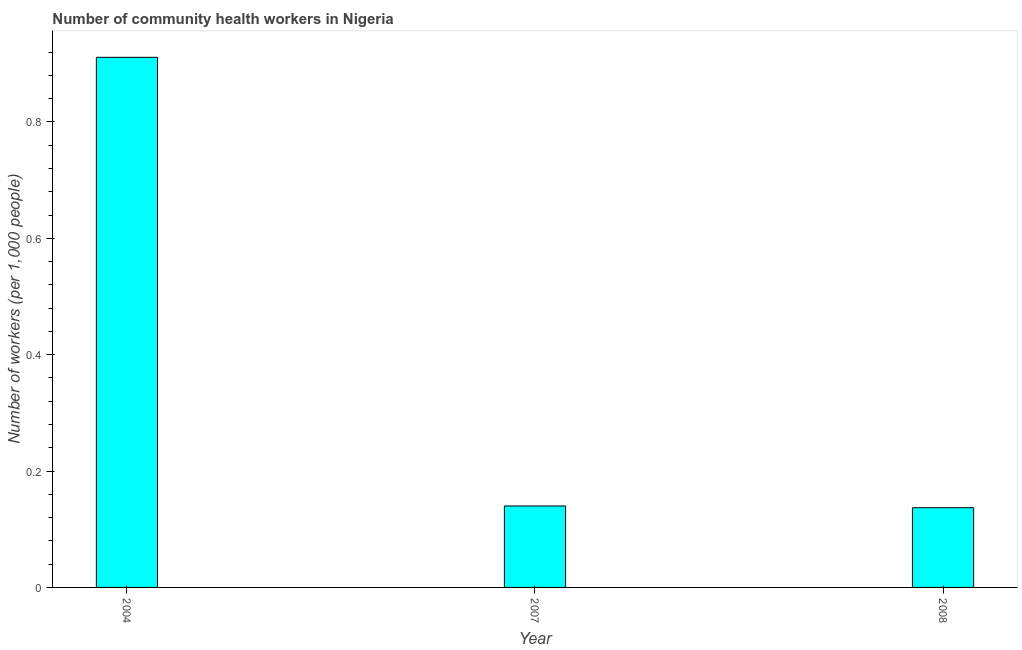Does the graph contain any zero values?
Make the answer very short. No. What is the title of the graph?
Keep it short and to the point. Number of community health workers in Nigeria. What is the label or title of the Y-axis?
Provide a succinct answer. Number of workers (per 1,0 people). What is the number of community health workers in 2008?
Your answer should be very brief. 0.14. Across all years, what is the maximum number of community health workers?
Your response must be concise. 0.91. Across all years, what is the minimum number of community health workers?
Keep it short and to the point. 0.14. What is the sum of the number of community health workers?
Keep it short and to the point. 1.19. What is the difference between the number of community health workers in 2004 and 2007?
Keep it short and to the point. 0.77. What is the average number of community health workers per year?
Give a very brief answer. 0.4. What is the median number of community health workers?
Offer a terse response. 0.14. In how many years, is the number of community health workers greater than 0.48 ?
Your response must be concise. 1. What is the ratio of the number of community health workers in 2004 to that in 2008?
Give a very brief answer. 6.65. Is the difference between the number of community health workers in 2007 and 2008 greater than the difference between any two years?
Provide a short and direct response. No. What is the difference between the highest and the second highest number of community health workers?
Ensure brevity in your answer.  0.77. What is the difference between the highest and the lowest number of community health workers?
Keep it short and to the point. 0.77. In how many years, is the number of community health workers greater than the average number of community health workers taken over all years?
Your answer should be compact. 1. What is the Number of workers (per 1,000 people) of 2004?
Ensure brevity in your answer.  0.91. What is the Number of workers (per 1,000 people) in 2007?
Give a very brief answer. 0.14. What is the Number of workers (per 1,000 people) in 2008?
Offer a very short reply. 0.14. What is the difference between the Number of workers (per 1,000 people) in 2004 and 2007?
Offer a very short reply. 0.77. What is the difference between the Number of workers (per 1,000 people) in 2004 and 2008?
Your response must be concise. 0.77. What is the difference between the Number of workers (per 1,000 people) in 2007 and 2008?
Provide a succinct answer. 0. What is the ratio of the Number of workers (per 1,000 people) in 2004 to that in 2007?
Your response must be concise. 6.51. What is the ratio of the Number of workers (per 1,000 people) in 2004 to that in 2008?
Keep it short and to the point. 6.65. 